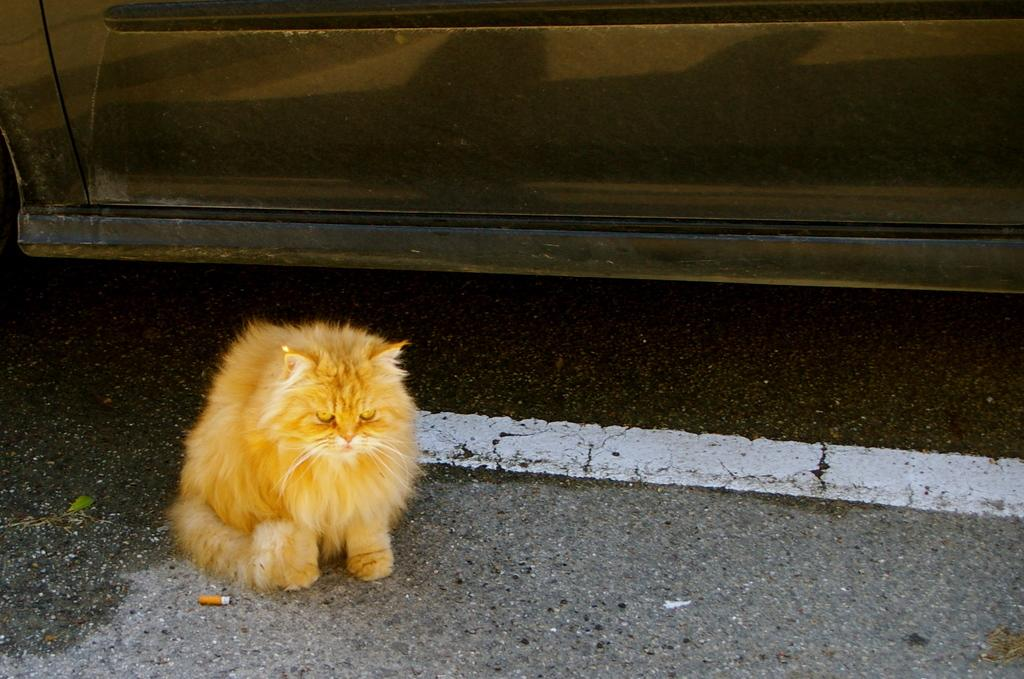What type of animal is in the image? There is a cat in the image. Where is the cat located in the image? The cat is sitting on the road. What else can be seen in the image besides the cat? There is a vehicle in the image. What part of the vehicle is visible in the image? The door of the vehicle is visible. What degree does the kitten need to become a veterinarian in the image? There is no kitten present in the image, and the cat in the image is not pursuing a degree or career. What type of art is displayed on the vehicle in the image? There is no art displayed on the vehicle in the image; only the door is visible. 